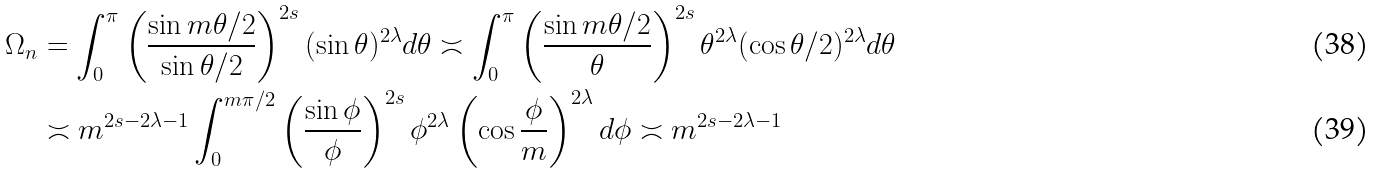<formula> <loc_0><loc_0><loc_500><loc_500>\Omega _ { n } & = \int _ { 0 } ^ { \pi } \left ( \frac { \sin m \theta / 2 } { \sin \theta / 2 } \right ) ^ { 2 s } ( \sin \theta ) ^ { 2 \lambda } d \theta \asymp \int _ { 0 } ^ { \pi } \left ( \frac { \sin m \theta / 2 } { \theta } \right ) ^ { 2 s } \theta ^ { 2 \lambda } ( \cos \theta / 2 ) ^ { 2 \lambda } d \theta \\ & \asymp m ^ { 2 s - 2 \lambda - 1 } \int _ { 0 } ^ { m \pi / 2 } \left ( \frac { \sin \phi } { \phi } \right ) ^ { 2 s } \phi ^ { 2 \lambda } \left ( \cos \frac { \phi } { m } \right ) ^ { 2 \lambda } d \phi \asymp m ^ { 2 s - 2 \lambda - 1 }</formula> 